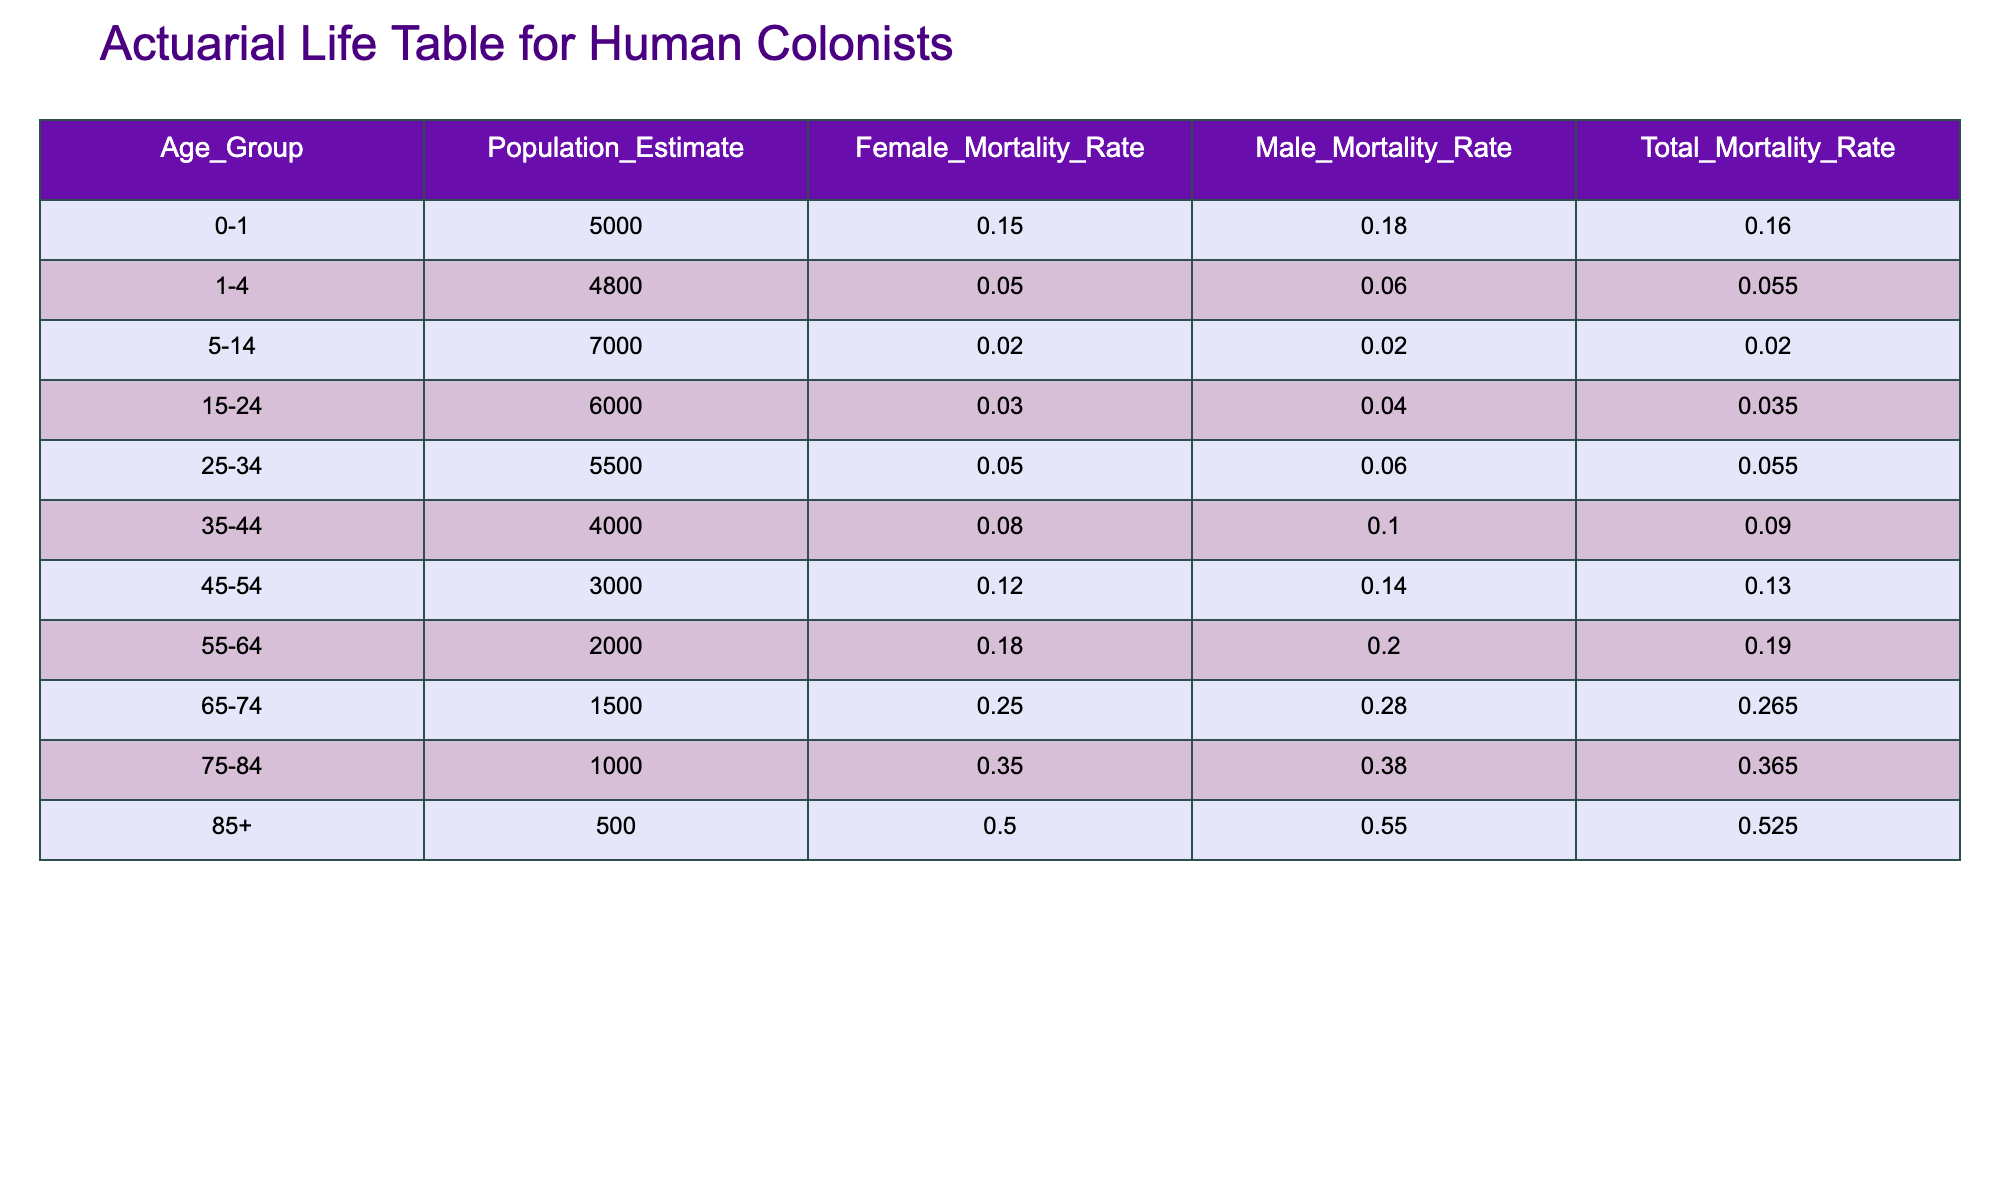What is the total mortality rate for ages 0-1? The total mortality rate for the age group 0-1 is provided directly in the table under the "Total Mortality Rate" column. Looking at that row, the rate is 0.16.
Answer: 0.16 What is the population estimate for individuals aged 55-64? The population estimate for the age group 55-64 is also listed in the table. The corresponding cell under "Population Estimate" gives the value of 2000.
Answer: 2000 Which age group has the highest female mortality rate? To find the highest female mortality rate, we look at the "Female Mortality Rate" column and identify the maximum value. The highest rate can be found in the age group 85+, which has a female mortality rate of 0.50.
Answer: 85+ What is the average total mortality rate for all age groups? To calculate the average total mortality rate, first, we sum all the rates: 0.16 + 0.055 + 0.02 + 0.035 + 0.055 + 0.09 + 0.13 + 0.19 + 0.265 + 0.365 + 0.525 = 1.845. Then, we divide by the number of age groups, which is 11. The average is 1.845 / 11 ≈ 0.16864.
Answer: 0.169 Are the male mortality rates increasing with age? To determine if the male mortality rates are increasing, we look at the "Male Mortality Rate" column and compare the values from each age group. The rates do increase from 0.18 (0-1) to 0.55 (85+), confirming that the rates overall rise with age, thus the answer is yes.
Answer: Yes What is the difference between the male mortality rate for ages 15-24 and ages 25-34? First, we find the male mortality rates for both age groups: 15-24 has a rate of 0.04, and 25-34 has a rate of 0.06. To get the difference, we subtract: 0.06 - 0.04 = 0.02.
Answer: 0.02 In which age group is the total mortality rate the lowest? By reviewing the "Total Mortality Rate" column, we find that the lowest total mortality rate is 0.02, corresponding to the age group 5-14.
Answer: 5-14 What percentage of the population estimate is represented by the age group 75-84? To find this percentage, we take the population estimate for the 75-84 age group, which is 1000, and divide it by the total population. The total population is the sum of all population estimates: 5000 + 4800 + 7000 + 6000 + 5500 + 4000 + 3000 + 2000 + 1500 + 1000 + 500 = 30,300. The percentage is (1000 / 30300) * 100 ≈ 3.30%.
Answer: 3.30% 